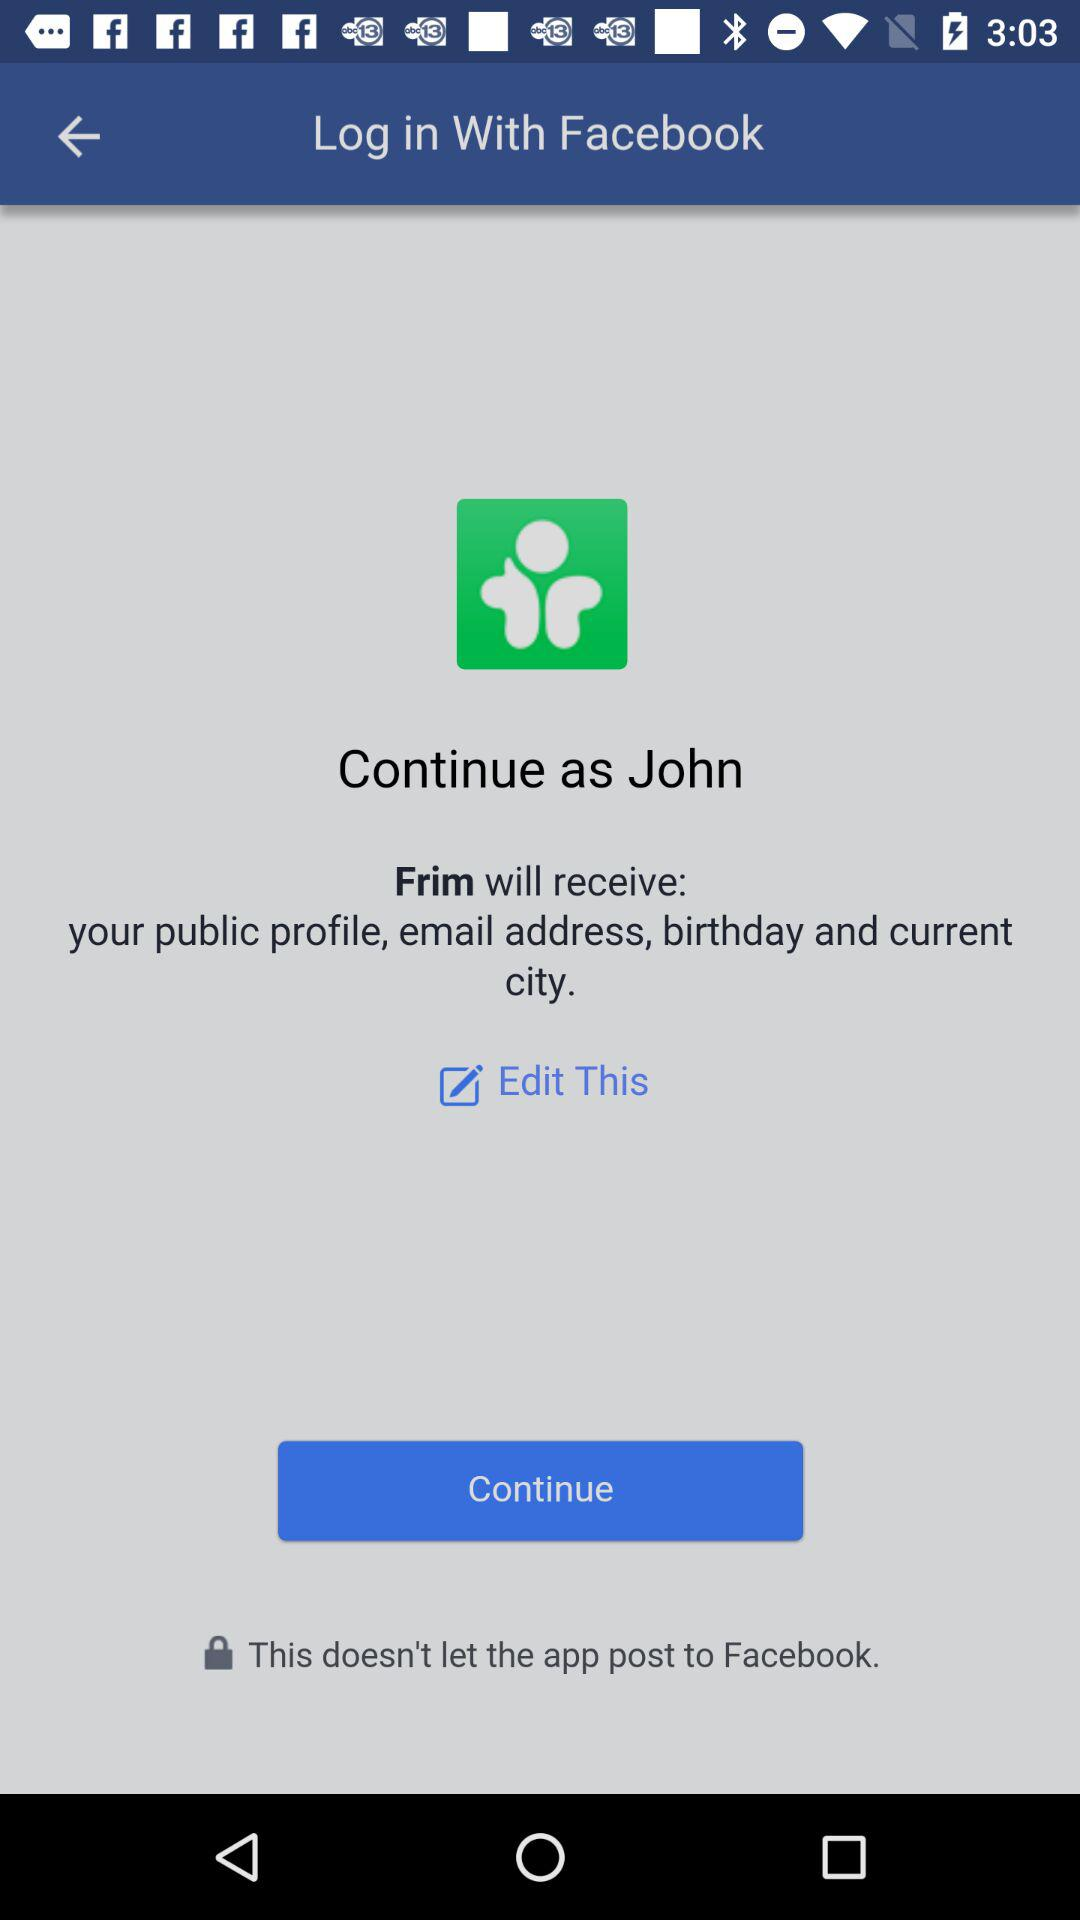How can we log in? You can log in with "Facebook". 